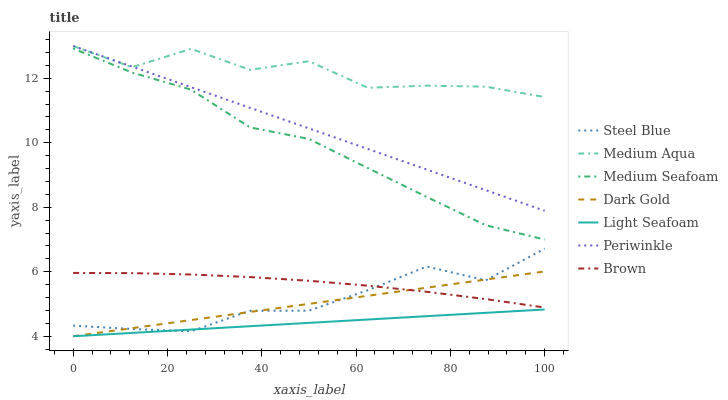Does Dark Gold have the minimum area under the curve?
Answer yes or no. No. Does Dark Gold have the maximum area under the curve?
Answer yes or no. No. Is Dark Gold the smoothest?
Answer yes or no. No. Is Dark Gold the roughest?
Answer yes or no. No. Does Steel Blue have the lowest value?
Answer yes or no. No. Does Dark Gold have the highest value?
Answer yes or no. No. Is Brown less than Medium Seafoam?
Answer yes or no. Yes. Is Brown greater than Light Seafoam?
Answer yes or no. Yes. Does Brown intersect Medium Seafoam?
Answer yes or no. No. 